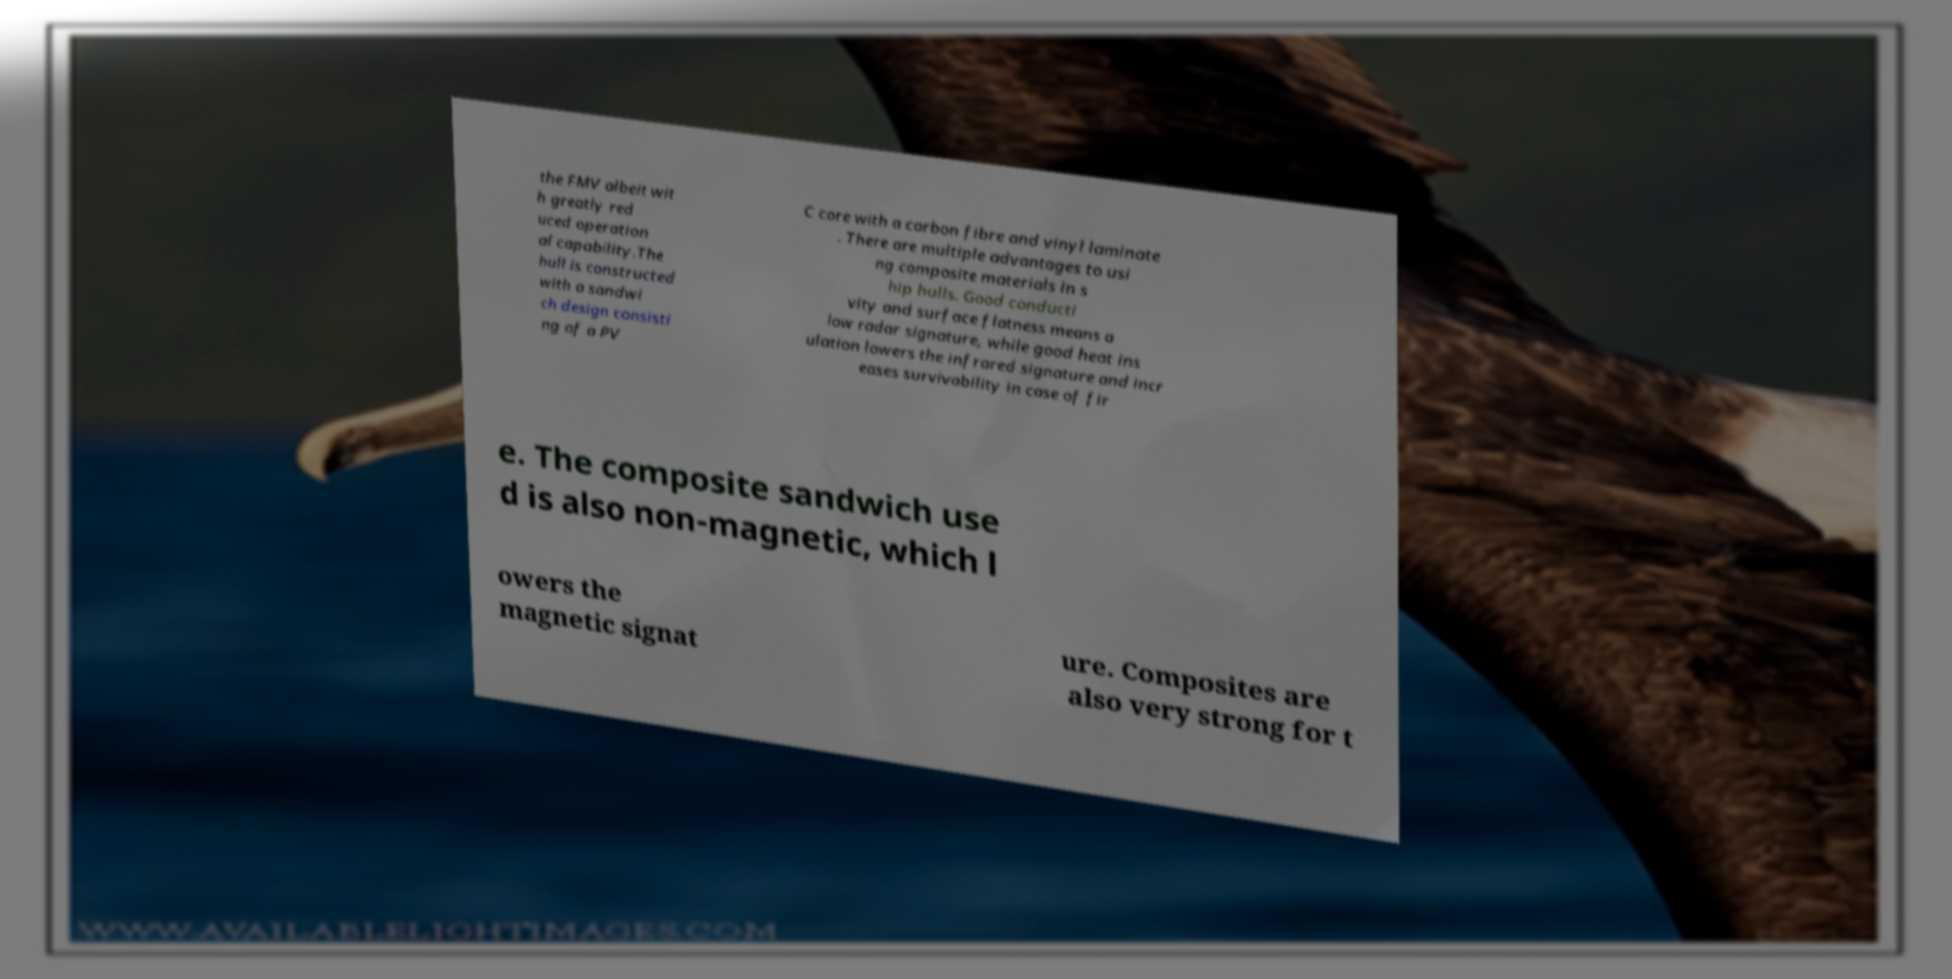Please identify and transcribe the text found in this image. the FMV albeit wit h greatly red uced operation al capability.The hull is constructed with a sandwi ch design consisti ng of a PV C core with a carbon fibre and vinyl laminate . There are multiple advantages to usi ng composite materials in s hip hulls. Good conducti vity and surface flatness means a low radar signature, while good heat ins ulation lowers the infrared signature and incr eases survivability in case of fir e. The composite sandwich use d is also non-magnetic, which l owers the magnetic signat ure. Composites are also very strong for t 